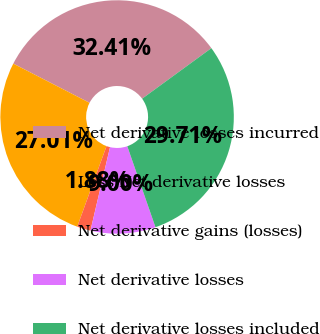Convert chart to OTSL. <chart><loc_0><loc_0><loc_500><loc_500><pie_chart><fcel>Net derivative losses incurred<fcel>Less Net derivative losses<fcel>Net derivative gains (losses)<fcel>Net derivative losses<fcel>Net derivative losses included<nl><fcel>32.41%<fcel>27.01%<fcel>1.88%<fcel>9.0%<fcel>29.71%<nl></chart> 